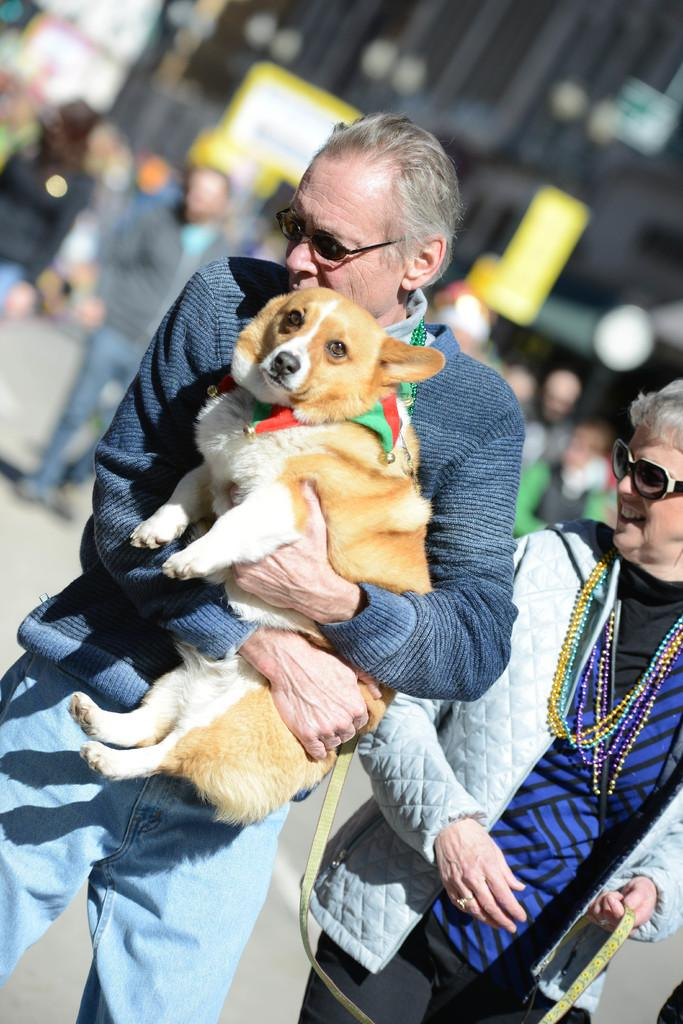What type of structure is visible in the image? There is a building in the image. Who or what else can be seen in the image? There are people and a dog in the image. What type of breakfast is the dog eating in the image? There is no breakfast present in the image, and the dog is not eating anything. 